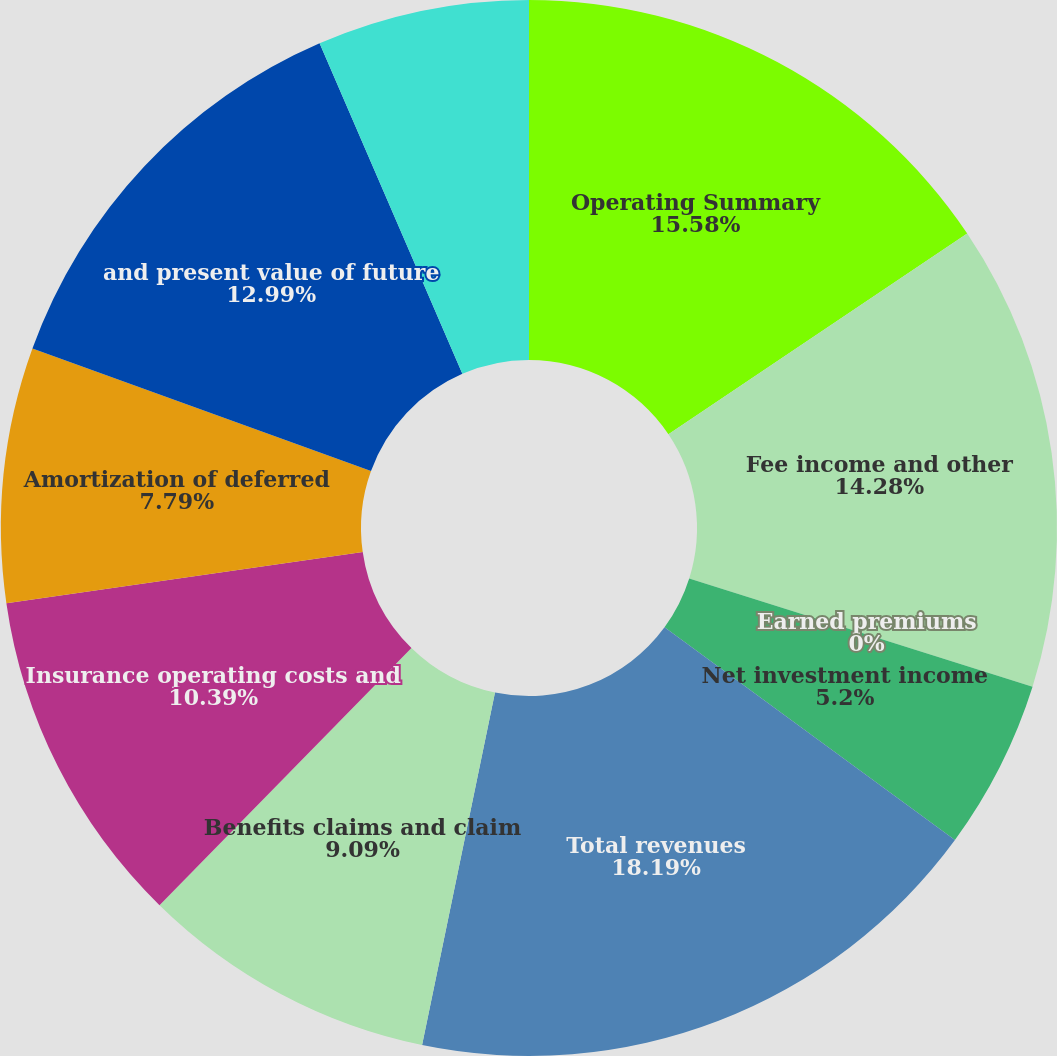<chart> <loc_0><loc_0><loc_500><loc_500><pie_chart><fcel>Operating Summary<fcel>Fee income and other<fcel>Earned premiums<fcel>Net investment income<fcel>Total revenues<fcel>Benefits claims and claim<fcel>Insurance operating costs and<fcel>Amortization of deferred<fcel>and present value of future<fcel>Income before income taxes and<nl><fcel>15.58%<fcel>14.28%<fcel>0.0%<fcel>5.2%<fcel>18.18%<fcel>9.09%<fcel>10.39%<fcel>7.79%<fcel>12.99%<fcel>6.49%<nl></chart> 